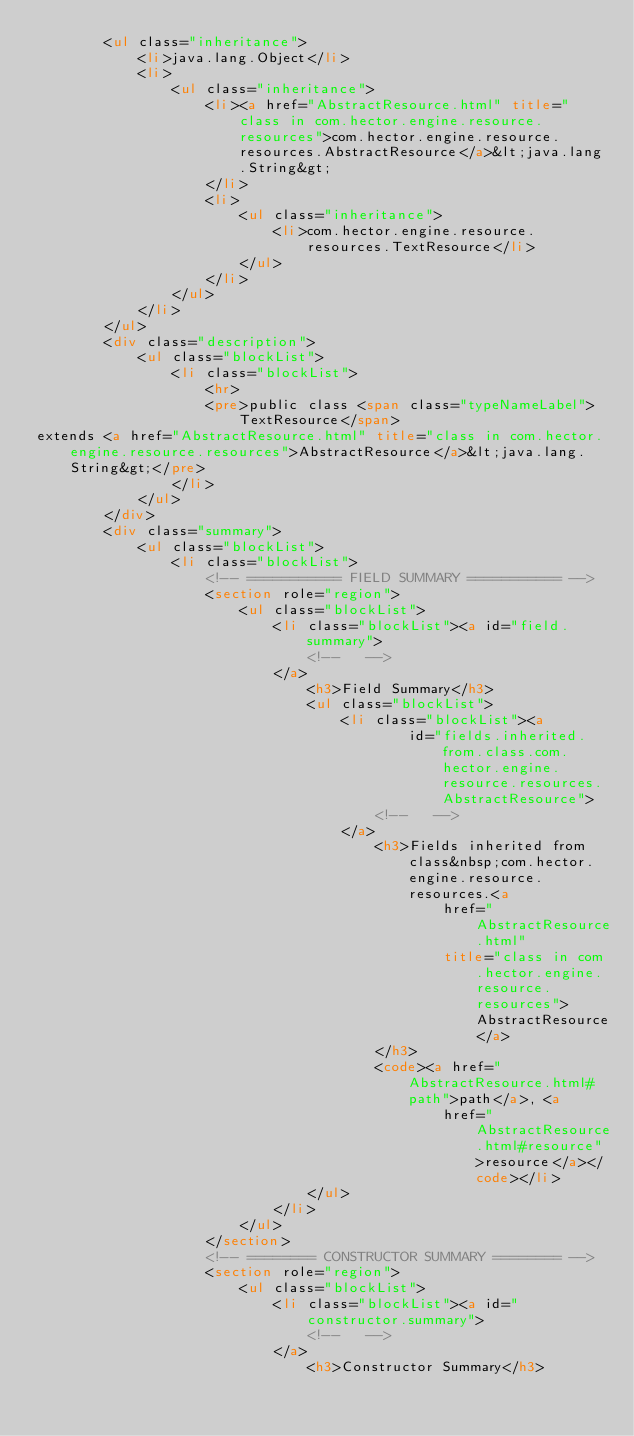Convert code to text. <code><loc_0><loc_0><loc_500><loc_500><_HTML_>        <ul class="inheritance">
            <li>java.lang.Object</li>
            <li>
                <ul class="inheritance">
                    <li><a href="AbstractResource.html" title="class in com.hector.engine.resource.resources">com.hector.engine.resource.resources.AbstractResource</a>&lt;java.lang.String&gt;
                    </li>
                    <li>
                        <ul class="inheritance">
                            <li>com.hector.engine.resource.resources.TextResource</li>
                        </ul>
                    </li>
                </ul>
            </li>
        </ul>
        <div class="description">
            <ul class="blockList">
                <li class="blockList">
                    <hr>
                    <pre>public class <span class="typeNameLabel">TextResource</span>
extends <a href="AbstractResource.html" title="class in com.hector.engine.resource.resources">AbstractResource</a>&lt;java.lang.String&gt;</pre>
                </li>
            </ul>
        </div>
        <div class="summary">
            <ul class="blockList">
                <li class="blockList">
                    <!-- =========== FIELD SUMMARY =========== -->
                    <section role="region">
                        <ul class="blockList">
                            <li class="blockList"><a id="field.summary">
                                <!--   -->
                            </a>
                                <h3>Field Summary</h3>
                                <ul class="blockList">
                                    <li class="blockList"><a
                                            id="fields.inherited.from.class.com.hector.engine.resource.resources.AbstractResource">
                                        <!--   -->
                                    </a>
                                        <h3>Fields inherited from class&nbsp;com.hector.engine.resource.resources.<a
                                                href="AbstractResource.html"
                                                title="class in com.hector.engine.resource.resources">AbstractResource</a>
                                        </h3>
                                        <code><a href="AbstractResource.html#path">path</a>, <a
                                                href="AbstractResource.html#resource">resource</a></code></li>
                                </ul>
                            </li>
                        </ul>
                    </section>
                    <!-- ======== CONSTRUCTOR SUMMARY ======== -->
                    <section role="region">
                        <ul class="blockList">
                            <li class="blockList"><a id="constructor.summary">
                                <!--   -->
                            </a>
                                <h3>Constructor Summary</h3></code> 